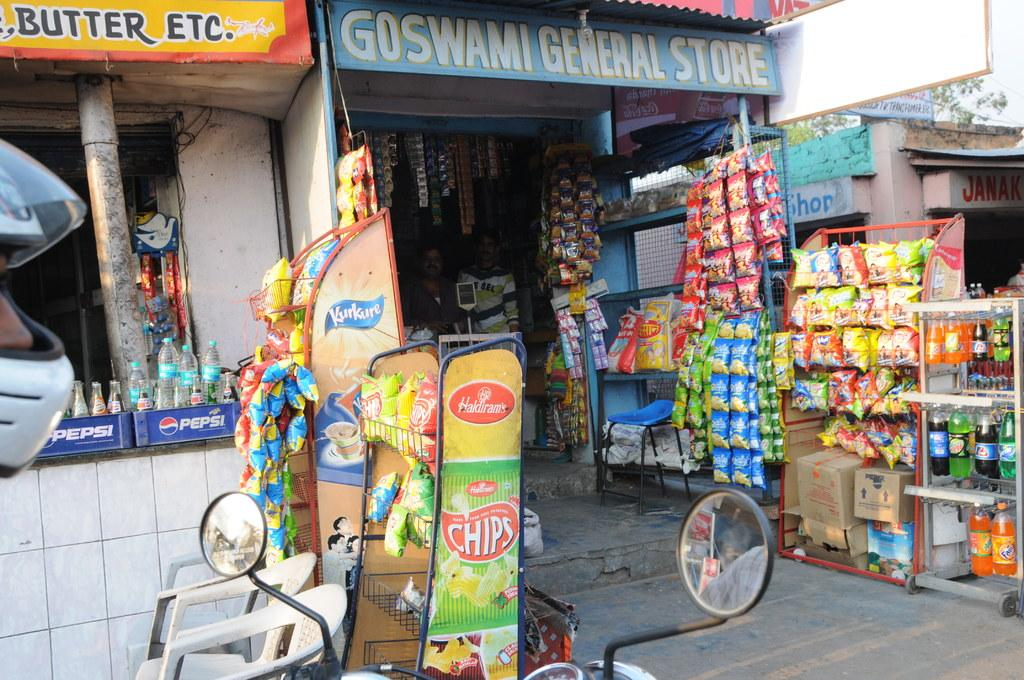<image>
Offer a succinct explanation of the picture presented. Pepsi, chips and other snack items are sold in small, run down shops. 